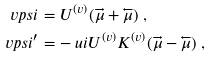<formula> <loc_0><loc_0><loc_500><loc_500>\ v p s i & = U ^ { ( v ) } ( \overrightarrow { \mu } + \overleftarrow { \mu } ) \ , \\ \ v p s i ^ { \prime } & = - \ u i U ^ { ( v ) } K ^ { ( v ) } ( \overrightarrow { \mu } - \overleftarrow { \mu } ) \ ,</formula> 